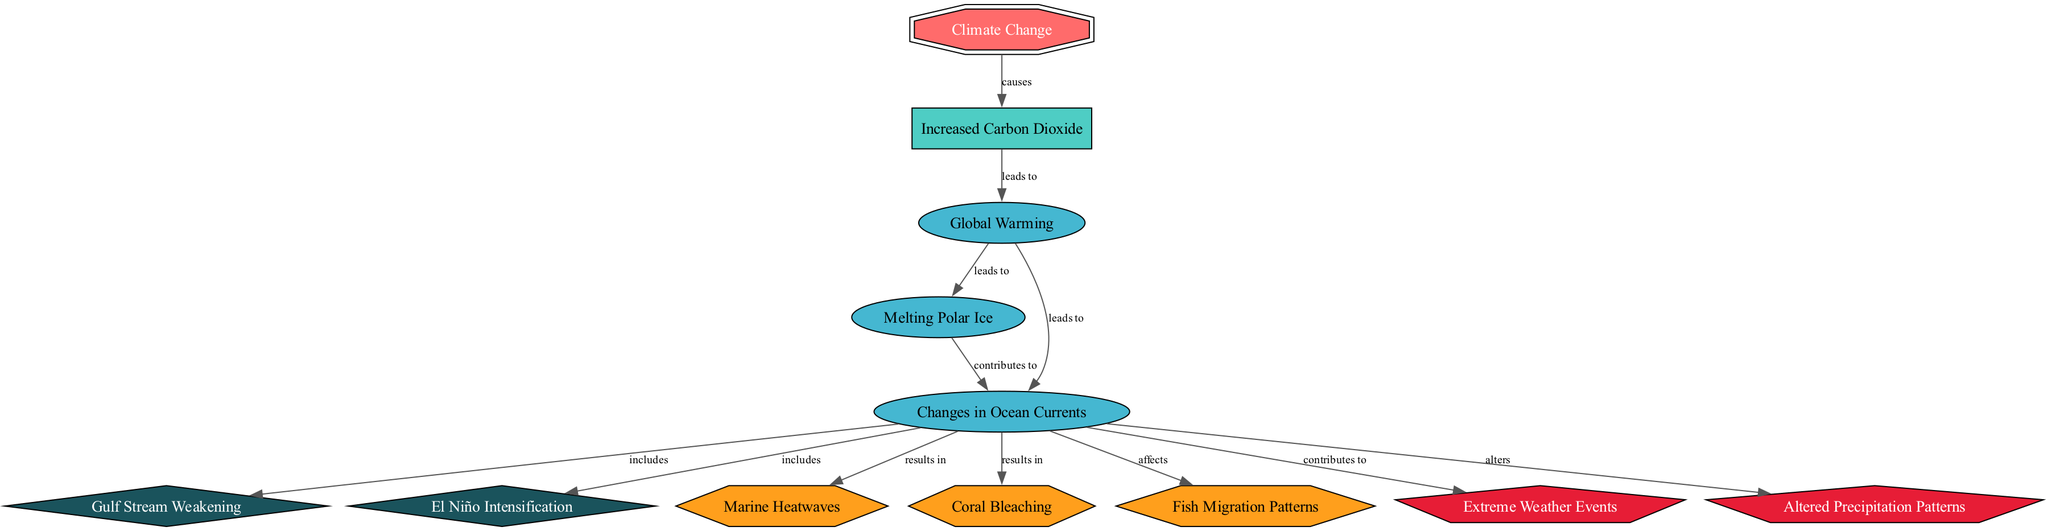What is the main cause of the changes depicted in the diagram? The diagram indicates that "Increased Carbon Dioxide" is the main cause that leads to subsequent effects related to climate change. This can be seen as the first edge originating from the main node "Climate Change."
Answer: Increased Carbon Dioxide How many ocean currents are identified in the diagram? By counting the nodes marked as "oceanCurrent," the diagram reveals two specific currents: "Gulf Stream Weakening" and "El Niño Intensification."
Answer: 2 What effect follows "Global Warming" in the diagram? The diagram shows two effects that follow "Global Warming": "Melting Polar Ice" and "Changes in Ocean Currents." Since the question asks for an immediate effect, "Melting Polar Ice" is the first effect listed.
Answer: Melting Polar Ice Which marine effect is directly linked to "Changes in Ocean Currents"? The edge from "Changes in Ocean Currents" points to multiple marine effects, but one is listed clearly as affecting fish migration patterns. This is a direct consequence shown in the diagram, demonstrating the impact of altered currents on marine species.
Answer: Fish Migration Patterns What relationship exists between "Changes in Ocean Currents" and "Extreme Weather Events"? The diagram indicates a direct relationship where "Changes in Ocean Currents" contributes to "Extreme Weather Events." This is shown by the edge labeled "contributes to," indicating a causal effect.
Answer: Contributes to How does "Melting Polar Ice" contribute to ocean current changes? The diagram shows an edge from "Melting Polar Ice" to "Changes in Ocean Currents," indicating that the former is a contributing factor to the alterations in ocean currents. This demonstrates how meltwater alters the dynamics of ocean circulation.
Answer: Contributes to What type of node is "Coral Bleaching"? The diagram categorizes "Coral Bleaching" as a "marineEffect," which is visually represented by a hexagon shape. This classification depicts its relation to the environmental effects induced by climate change.
Answer: Marine Effect What happens to precipitation patterns due to climate-related changes? The diagram shows that "Changes in Ocean Currents" alters "Precipitation Patterns," which indicates how shifts in oceanic conditions can impact weather systems and rain distribution. This connection signifies the broader implications of oceanic changes.
Answer: Alters 